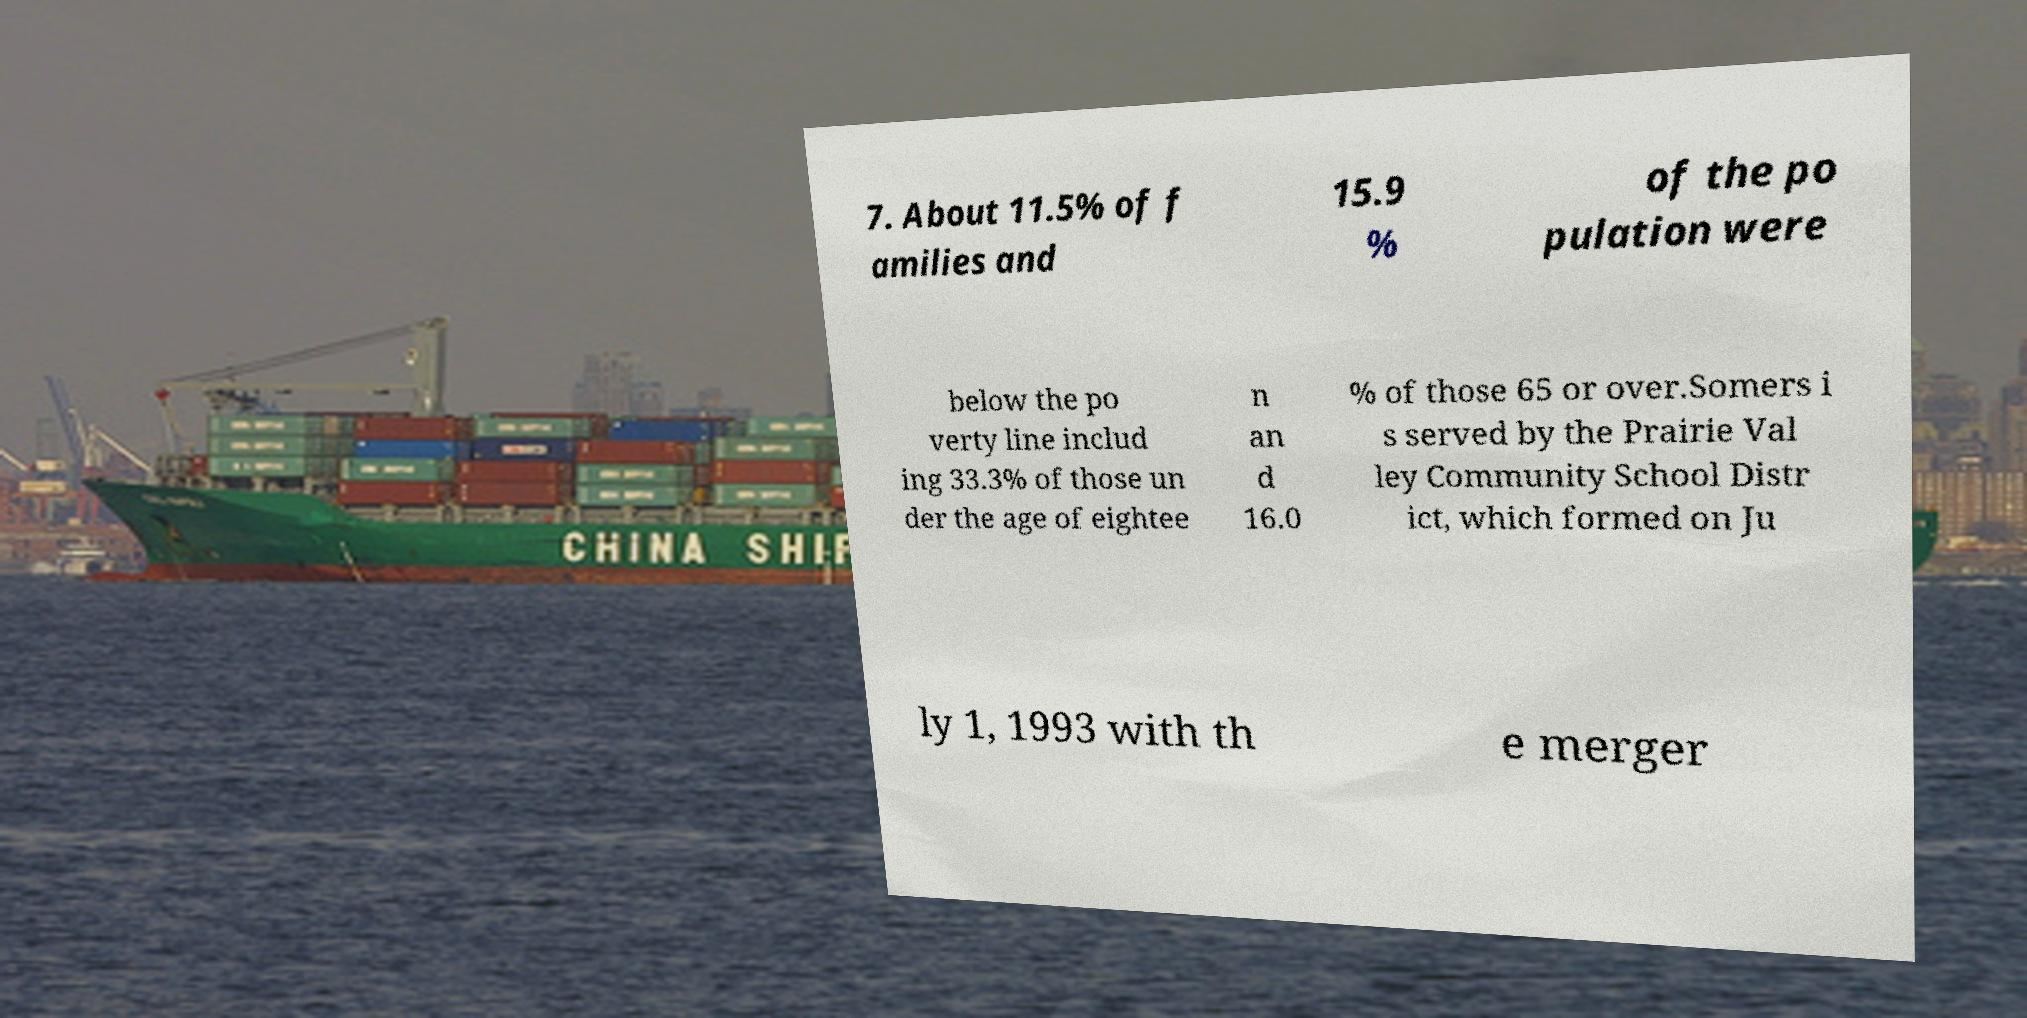Please read and relay the text visible in this image. What does it say? 7. About 11.5% of f amilies and 15.9 % of the po pulation were below the po verty line includ ing 33.3% of those un der the age of eightee n an d 16.0 % of those 65 or over.Somers i s served by the Prairie Val ley Community School Distr ict, which formed on Ju ly 1, 1993 with th e merger 